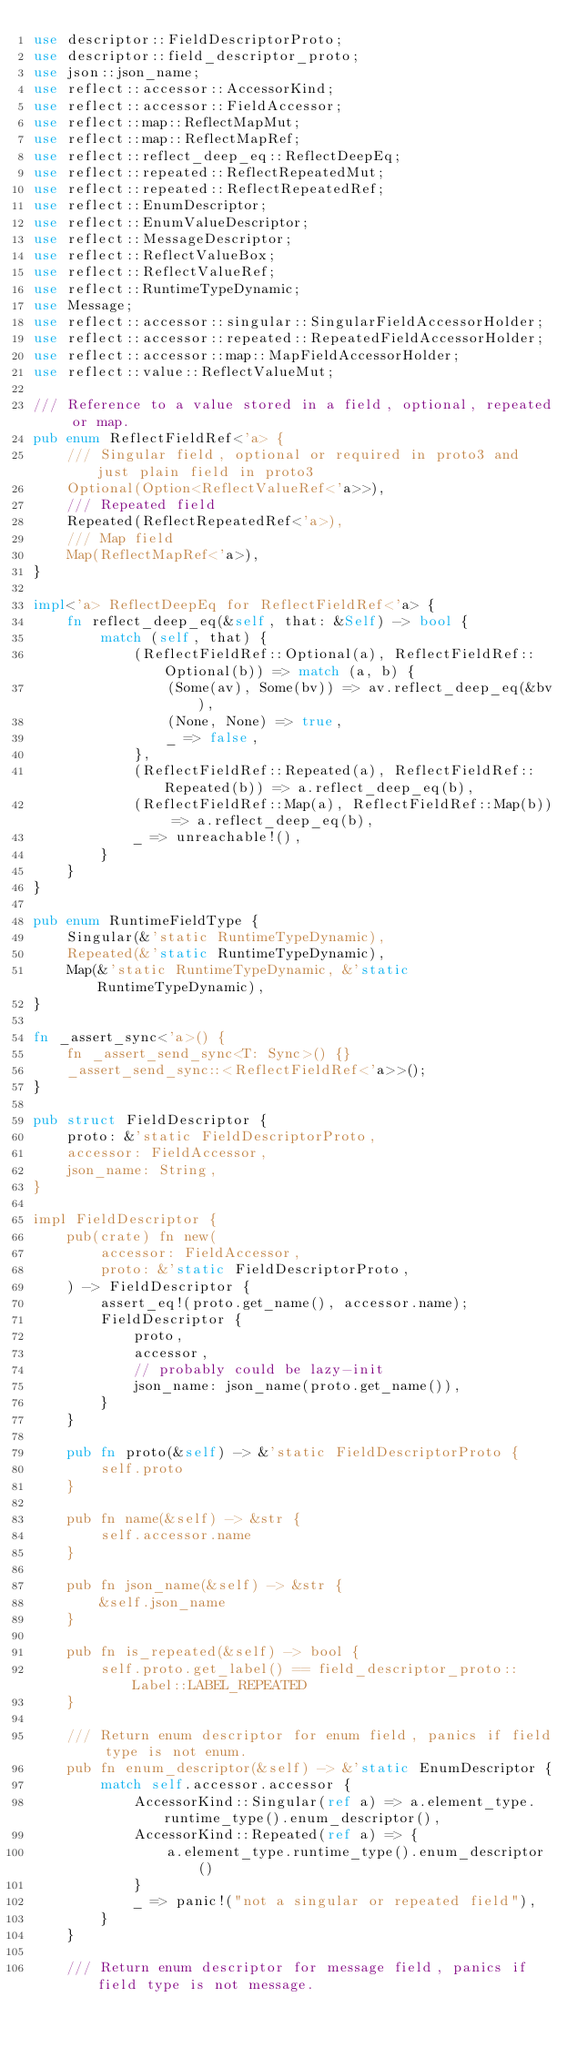<code> <loc_0><loc_0><loc_500><loc_500><_Rust_>use descriptor::FieldDescriptorProto;
use descriptor::field_descriptor_proto;
use json::json_name;
use reflect::accessor::AccessorKind;
use reflect::accessor::FieldAccessor;
use reflect::map::ReflectMapMut;
use reflect::map::ReflectMapRef;
use reflect::reflect_deep_eq::ReflectDeepEq;
use reflect::repeated::ReflectRepeatedMut;
use reflect::repeated::ReflectRepeatedRef;
use reflect::EnumDescriptor;
use reflect::EnumValueDescriptor;
use reflect::MessageDescriptor;
use reflect::ReflectValueBox;
use reflect::ReflectValueRef;
use reflect::RuntimeTypeDynamic;
use Message;
use reflect::accessor::singular::SingularFieldAccessorHolder;
use reflect::accessor::repeated::RepeatedFieldAccessorHolder;
use reflect::accessor::map::MapFieldAccessorHolder;
use reflect::value::ReflectValueMut;

/// Reference to a value stored in a field, optional, repeated or map.
pub enum ReflectFieldRef<'a> {
    /// Singular field, optional or required in proto3 and just plain field in proto3
    Optional(Option<ReflectValueRef<'a>>),
    /// Repeated field
    Repeated(ReflectRepeatedRef<'a>),
    /// Map field
    Map(ReflectMapRef<'a>),
}

impl<'a> ReflectDeepEq for ReflectFieldRef<'a> {
    fn reflect_deep_eq(&self, that: &Self) -> bool {
        match (self, that) {
            (ReflectFieldRef::Optional(a), ReflectFieldRef::Optional(b)) => match (a, b) {
                (Some(av), Some(bv)) => av.reflect_deep_eq(&bv),
                (None, None) => true,
                _ => false,
            },
            (ReflectFieldRef::Repeated(a), ReflectFieldRef::Repeated(b)) => a.reflect_deep_eq(b),
            (ReflectFieldRef::Map(a), ReflectFieldRef::Map(b)) => a.reflect_deep_eq(b),
            _ => unreachable!(),
        }
    }
}

pub enum RuntimeFieldType {
    Singular(&'static RuntimeTypeDynamic),
    Repeated(&'static RuntimeTypeDynamic),
    Map(&'static RuntimeTypeDynamic, &'static RuntimeTypeDynamic),
}

fn _assert_sync<'a>() {
    fn _assert_send_sync<T: Sync>() {}
    _assert_send_sync::<ReflectFieldRef<'a>>();
}

pub struct FieldDescriptor {
    proto: &'static FieldDescriptorProto,
    accessor: FieldAccessor,
    json_name: String,
}

impl FieldDescriptor {
    pub(crate) fn new(
        accessor: FieldAccessor,
        proto: &'static FieldDescriptorProto,
    ) -> FieldDescriptor {
        assert_eq!(proto.get_name(), accessor.name);
        FieldDescriptor {
            proto,
            accessor,
            // probably could be lazy-init
            json_name: json_name(proto.get_name()),
        }
    }

    pub fn proto(&self) -> &'static FieldDescriptorProto {
        self.proto
    }

    pub fn name(&self) -> &str {
        self.accessor.name
    }

    pub fn json_name(&self) -> &str {
        &self.json_name
    }

    pub fn is_repeated(&self) -> bool {
        self.proto.get_label() == field_descriptor_proto::Label::LABEL_REPEATED
    }

    /// Return enum descriptor for enum field, panics if field type is not enum.
    pub fn enum_descriptor(&self) -> &'static EnumDescriptor {
        match self.accessor.accessor {
            AccessorKind::Singular(ref a) => a.element_type.runtime_type().enum_descriptor(),
            AccessorKind::Repeated(ref a) => {
                a.element_type.runtime_type().enum_descriptor()
            }
            _ => panic!("not a singular or repeated field"),
        }
    }

    /// Return enum descriptor for message field, panics if field type is not message.</code> 